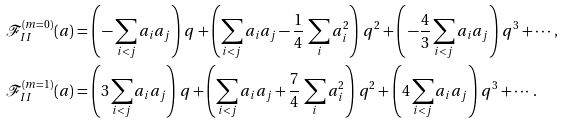Convert formula to latex. <formula><loc_0><loc_0><loc_500><loc_500>\, { \mathcal { F } } _ { I I } ^ { ( m = 0 ) } ( a ) & = \left ( \, - \sum _ { i < j } a _ { i } a _ { j } \right ) \, q + \left ( \sum _ { i < j } a _ { i } a _ { j } - \frac { 1 } { 4 } \, \sum _ { i } a _ { i } ^ { 2 } \right ) \, q ^ { 2 } + \left ( \, - \frac { 4 } { 3 } \sum _ { i < j } a _ { i } a _ { j } \right ) \, q ^ { 3 } + \cdots , \\ \, { \mathcal { F } } _ { I I } ^ { ( m = 1 ) } ( a ) & = \left ( 3 \sum _ { i < j } a _ { i } a _ { j } \right ) \, q + \left ( \sum _ { i < j } a _ { i } a _ { j } + \frac { 7 } { 4 } \, \sum _ { i } a _ { i } ^ { 2 } \right ) \, q ^ { 2 } + \left ( 4 \sum _ { i < j } a _ { i } a _ { j } \right ) \, q ^ { 3 } + \cdots .</formula> 